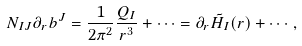Convert formula to latex. <formula><loc_0><loc_0><loc_500><loc_500>N _ { I J } \partial _ { r } b ^ { J } = \frac { 1 } { 2 \pi ^ { 2 } } \frac { Q _ { I } } { r ^ { 3 } } + \cdots = \partial _ { r } \tilde { H } _ { I } ( r ) + \cdots \, ,</formula> 